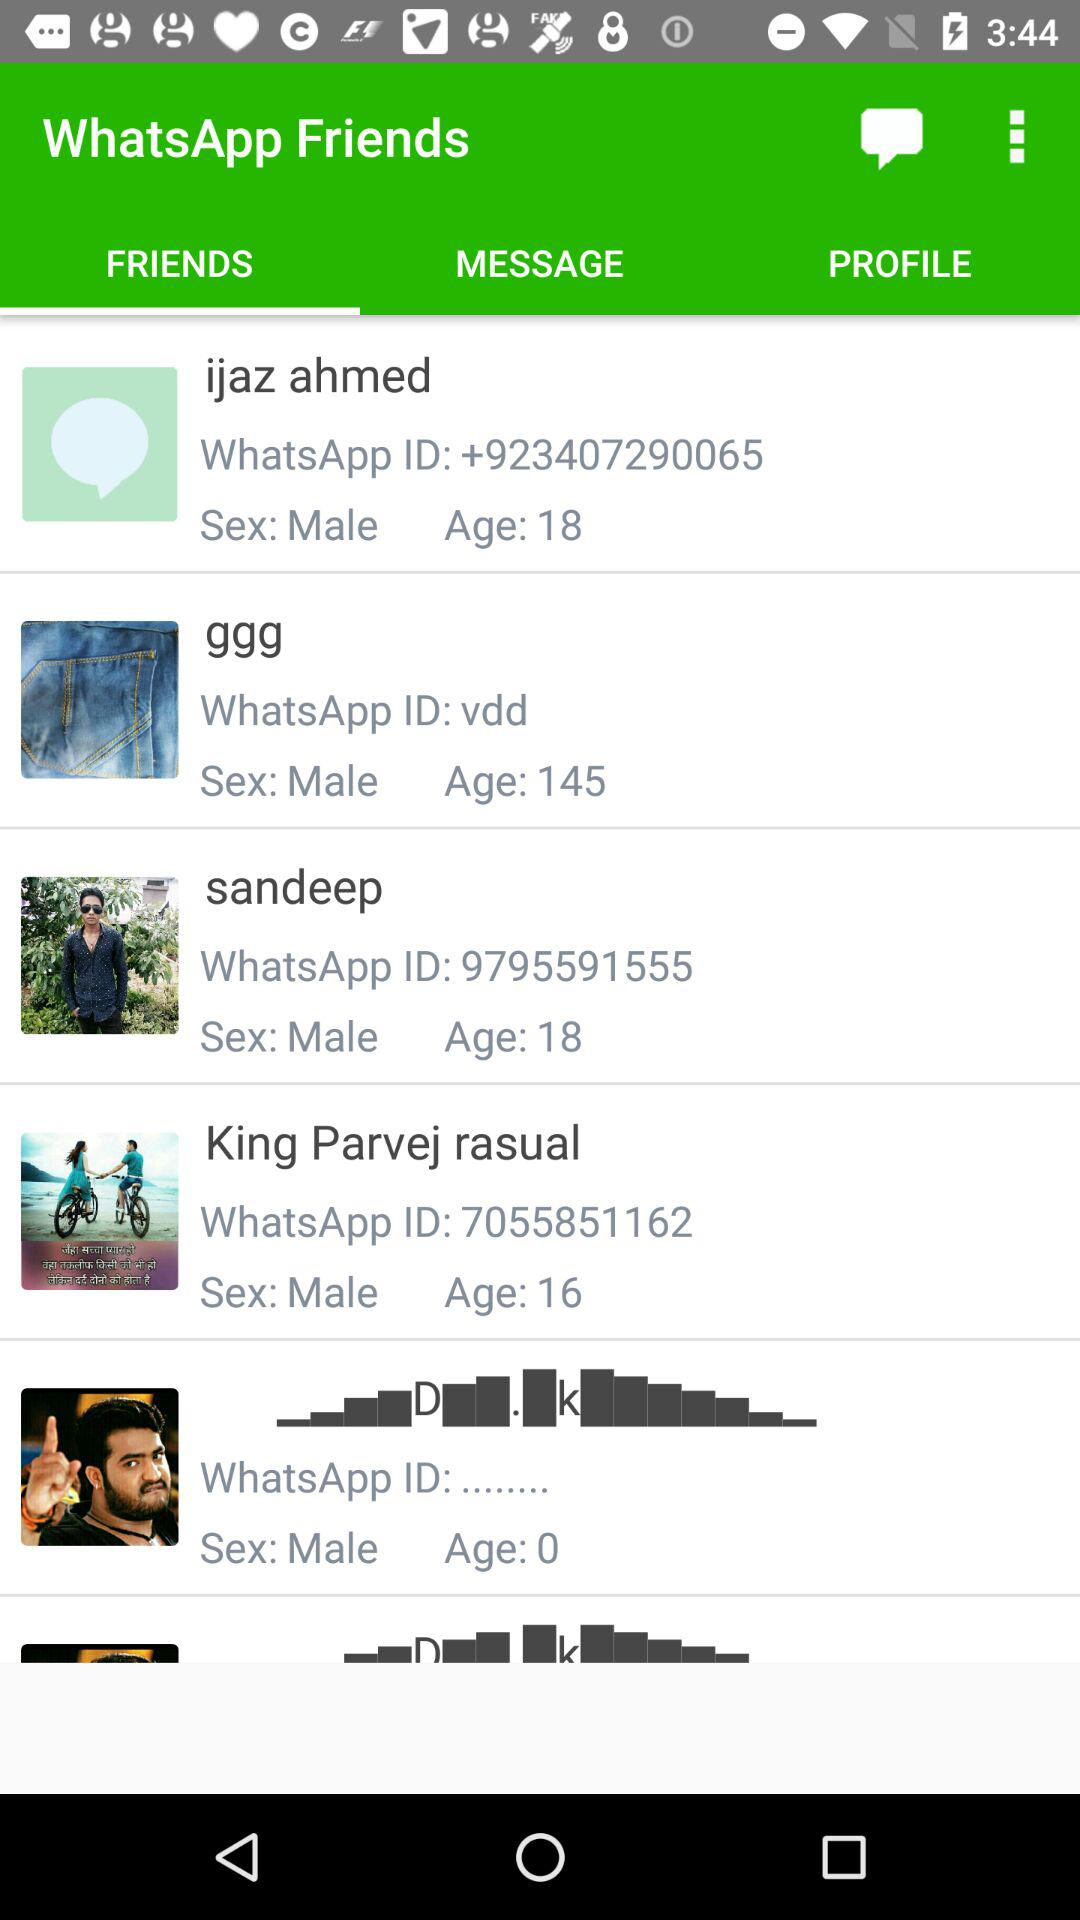When was the last message sent?
When the provided information is insufficient, respond with <no answer>. <no answer> 